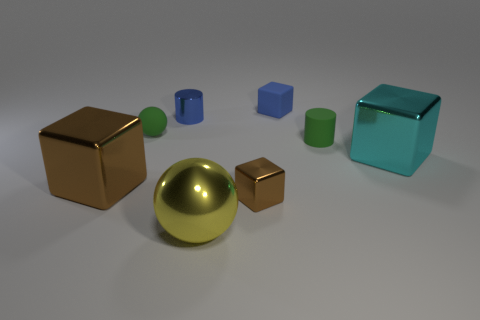How many other things are there of the same size as the green matte sphere?
Keep it short and to the point. 4. There is a small matte thing that is the same color as the tiny matte ball; what shape is it?
Keep it short and to the point. Cylinder. How many other things are the same shape as the big yellow thing?
Ensure brevity in your answer.  1. What size is the cyan object that is made of the same material as the large yellow object?
Your answer should be very brief. Large. Are there an equal number of big yellow metallic objects on the left side of the blue cylinder and small cylinders?
Your response must be concise. No. Do the rubber cylinder and the shiny cylinder have the same color?
Make the answer very short. No. There is a brown thing on the right side of the big brown metallic cube; does it have the same shape as the tiny green object to the right of the tiny blue metallic cylinder?
Ensure brevity in your answer.  No. What material is the tiny brown thing that is the same shape as the cyan metal object?
Make the answer very short. Metal. What is the color of the large metal object that is on the right side of the tiny blue cylinder and behind the tiny brown object?
Give a very brief answer. Cyan. Is there a small blue rubber block that is in front of the rubber object to the left of the tiny block behind the cyan metal object?
Provide a succinct answer. No. 